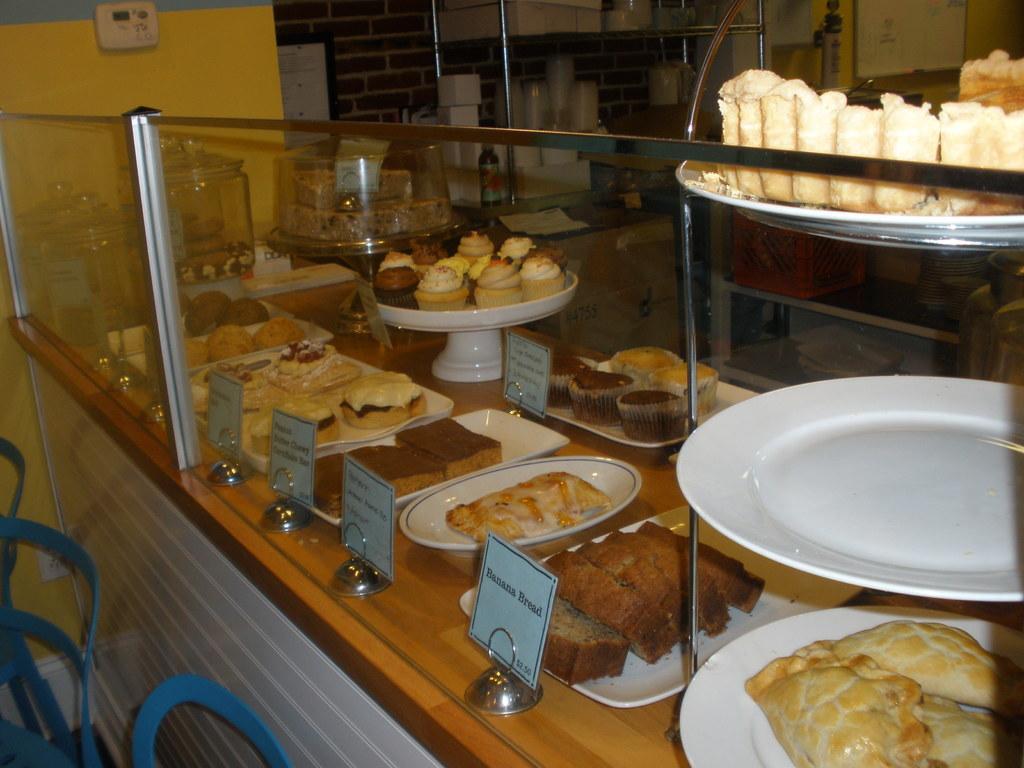Please provide a concise description of this image. In this picture there are few eatables placed in the right corner and there are some other objects in the background. 